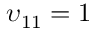Convert formula to latex. <formula><loc_0><loc_0><loc_500><loc_500>\upsilon _ { 1 1 } = 1</formula> 